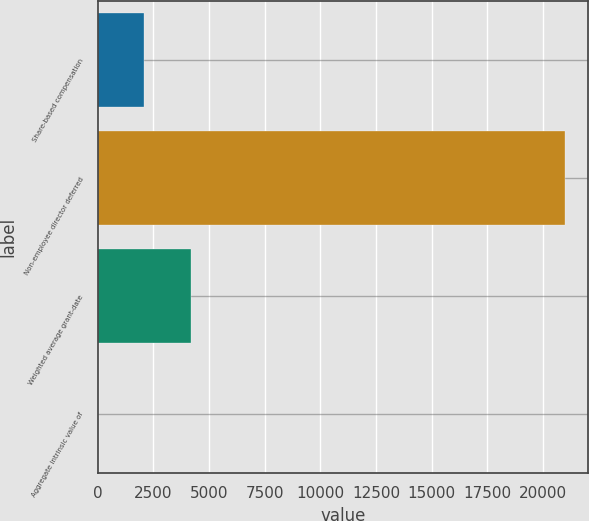<chart> <loc_0><loc_0><loc_500><loc_500><bar_chart><fcel>Share-based compensation<fcel>Non-employee director deferred<fcel>Weighted average grant-date<fcel>Aggregate intrinsic value of<nl><fcel>2100.72<fcel>21000<fcel>4200.64<fcel>0.8<nl></chart> 